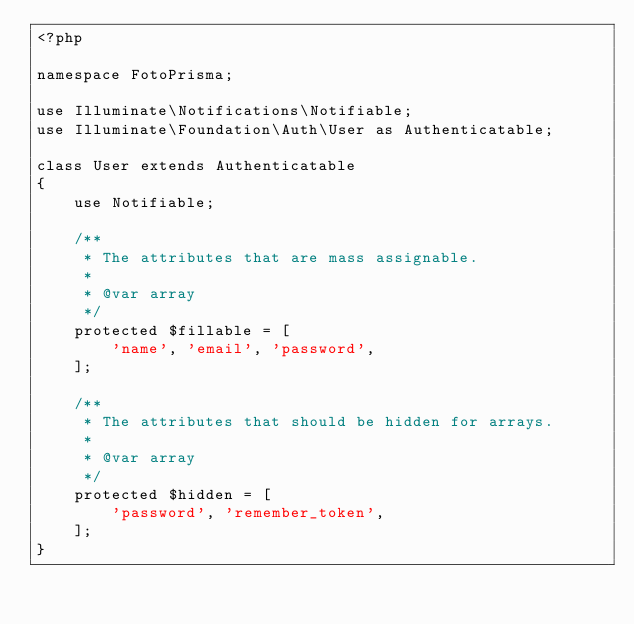<code> <loc_0><loc_0><loc_500><loc_500><_PHP_><?php

namespace FotoPrisma;

use Illuminate\Notifications\Notifiable;
use Illuminate\Foundation\Auth\User as Authenticatable;

class User extends Authenticatable
{
    use Notifiable;

    /**
     * The attributes that are mass assignable.
     *
     * @var array
     */
    protected $fillable = [
        'name', 'email', 'password',
    ];

    /**
     * The attributes that should be hidden for arrays.
     *
     * @var array
     */
    protected $hidden = [
        'password', 'remember_token',
    ];
}
</code> 